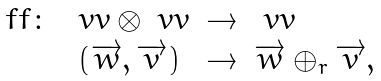Convert formula to latex. <formula><loc_0><loc_0><loc_500><loc_500>\begin{array} { r c c l } \ f f \colon & \ v v \otimes \ v v & \rightarrow & \ v v \\ & ( \overrightarrow { w } , \overrightarrow { v } ) & \rightarrow & \overrightarrow { w } \oplus _ { r } \overrightarrow { v } , \end{array}</formula> 